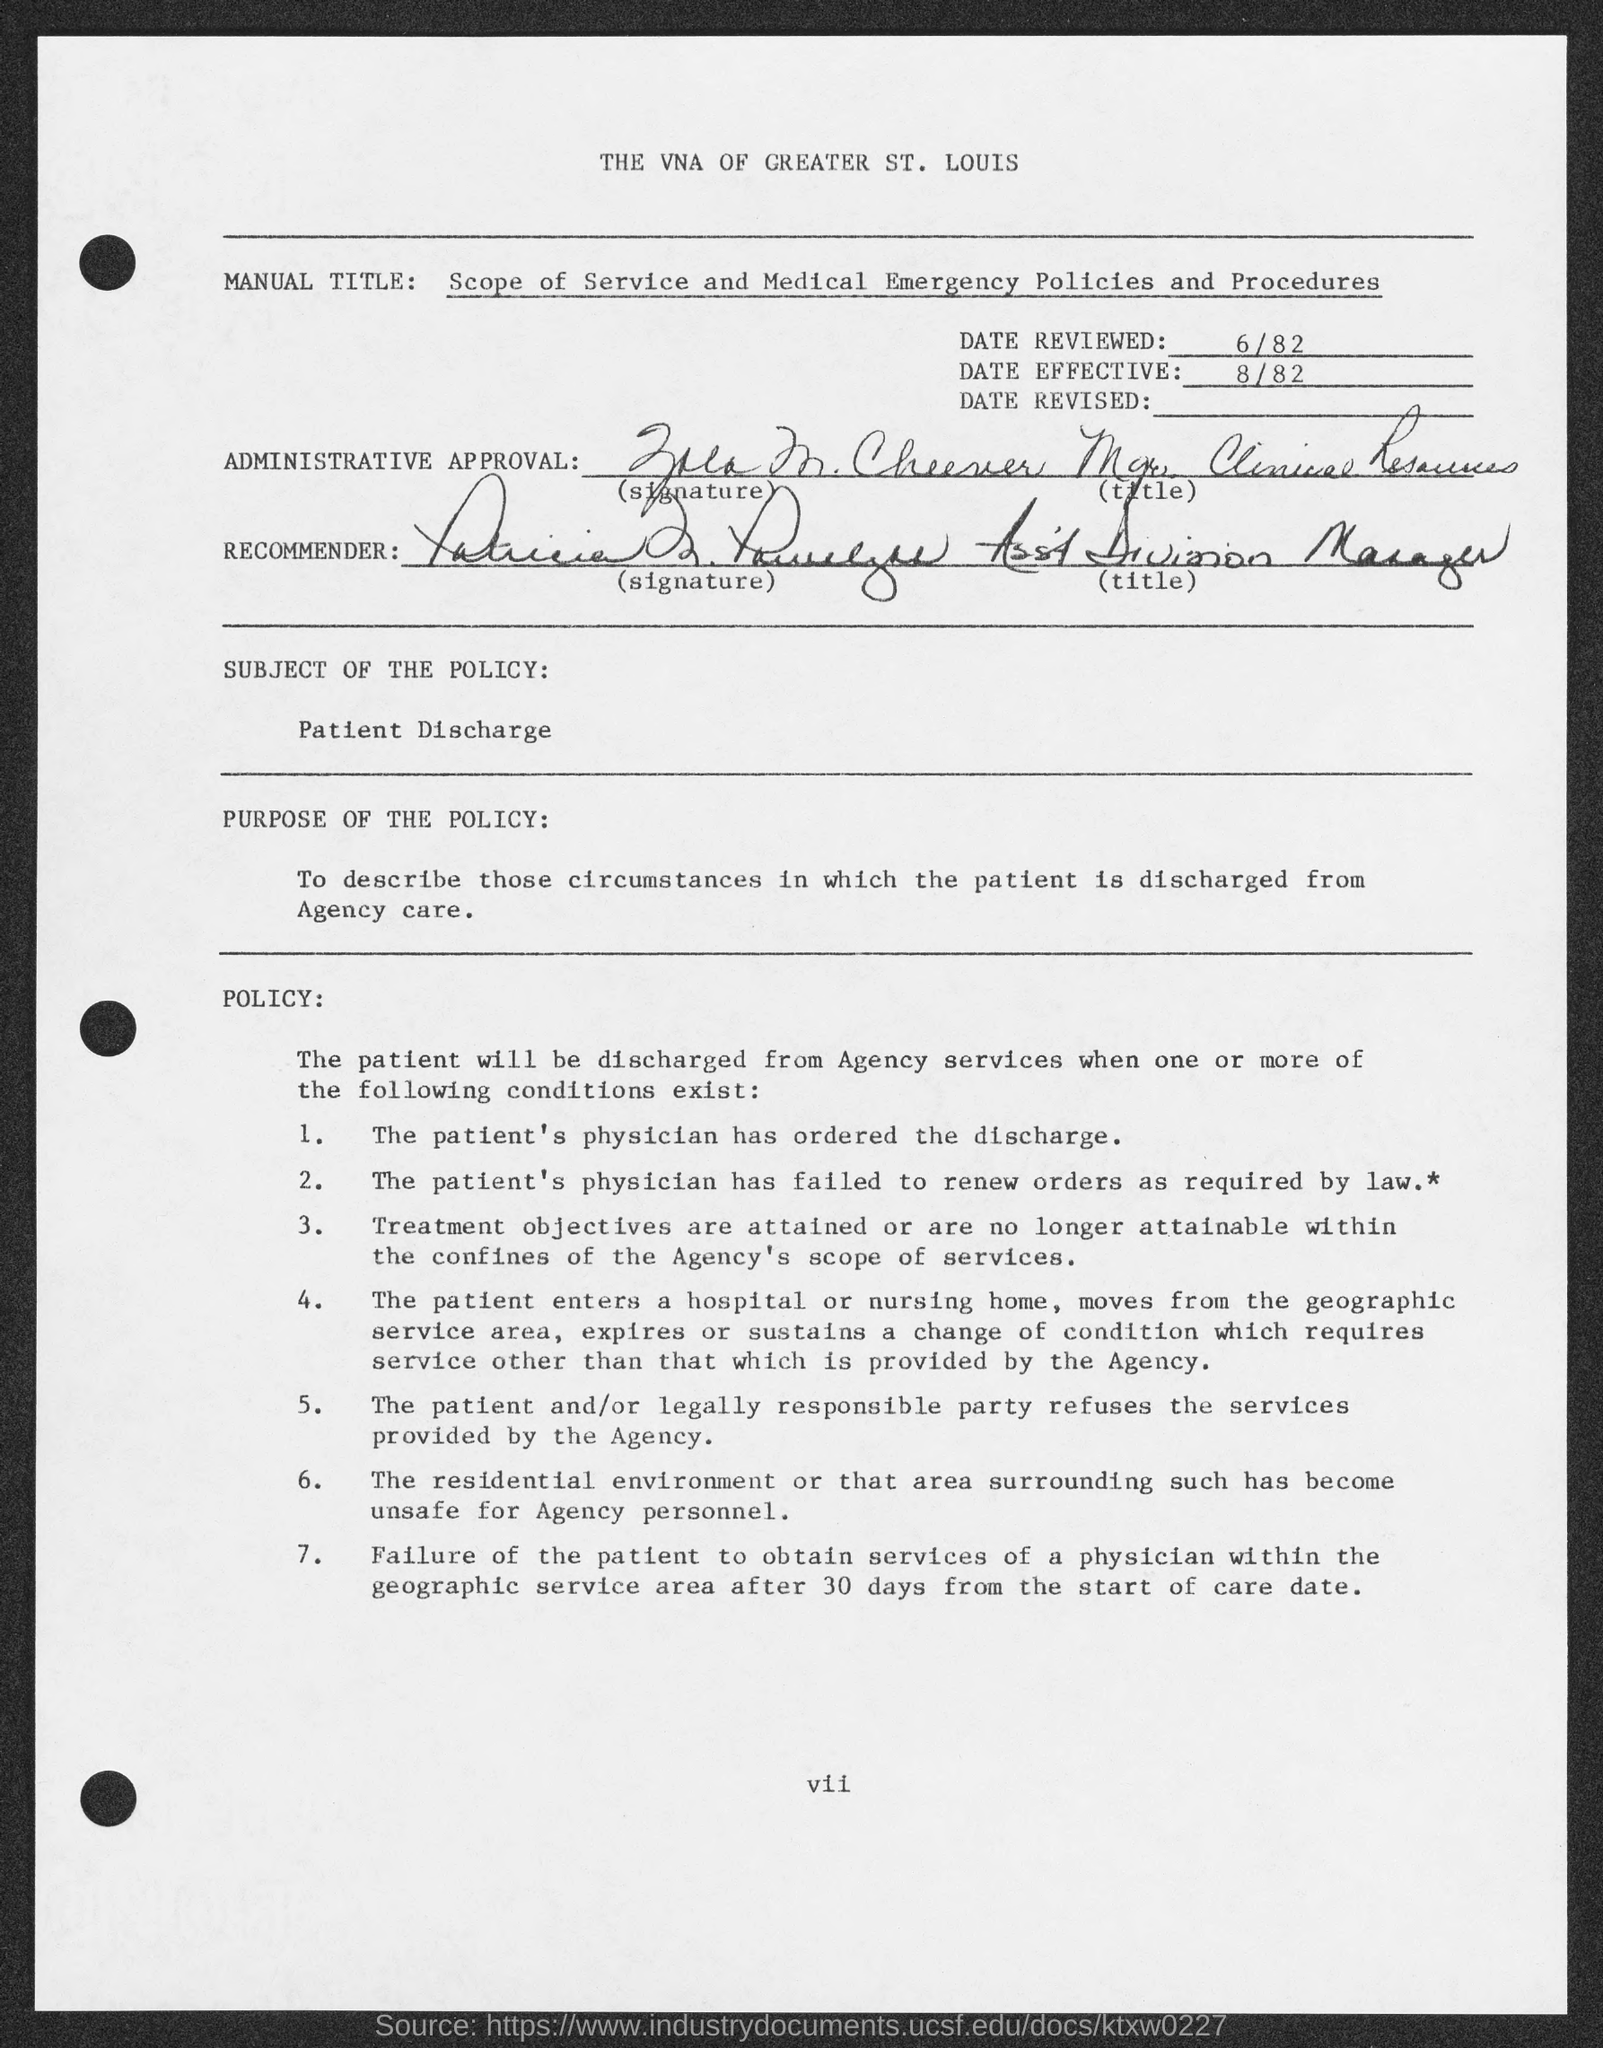What is the MANUAL TITLE of the document?
Your answer should be compact. Scope of service and medical emergency Policies and procedures. 